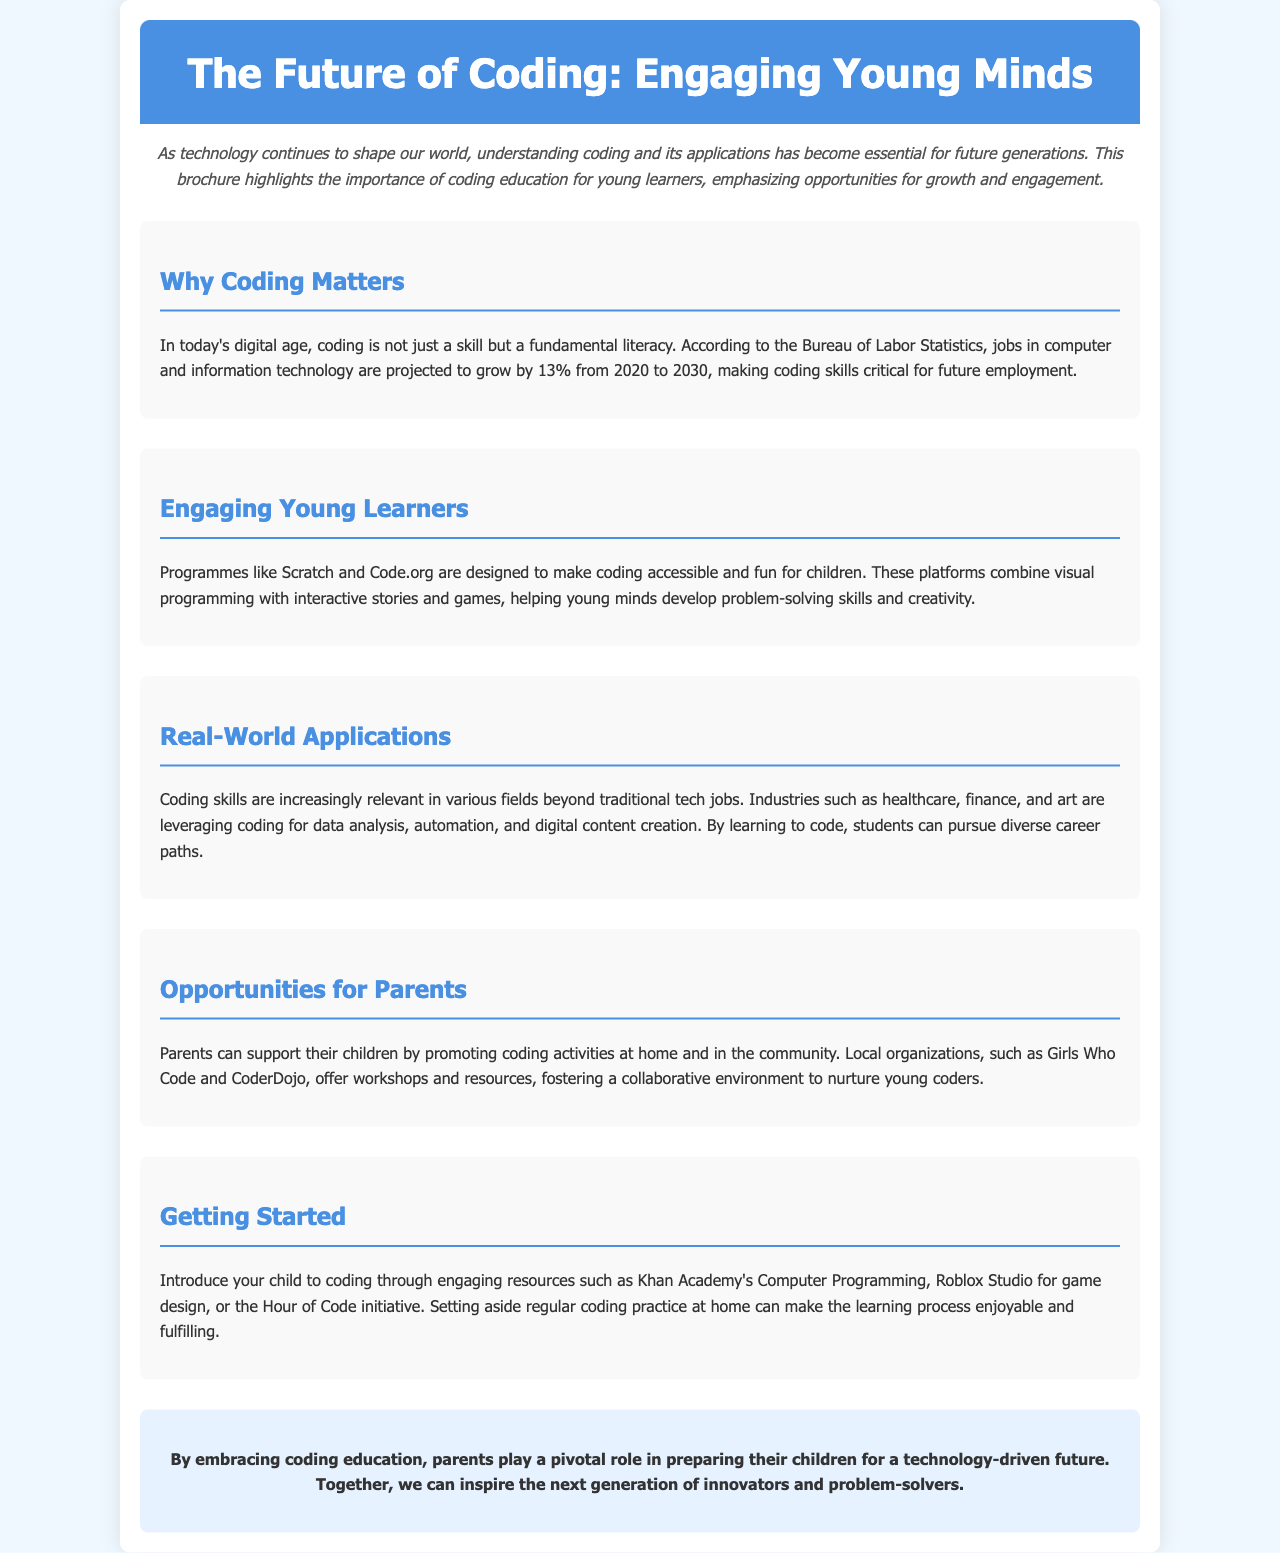What is the title of the brochure? The title is prominently displayed at the top of the brochure, indicating its main theme.
Answer: The Future of Coding: Engaging Young Minds What percentage is the projected job growth in computer and information technology from 2020 to 2030? The document refers to a specific percentage concerning future job growth based on statistics.
Answer: 13% Which platforms are mentioned as engaging young learners in coding? The brochure lists specific programs that are designed to make coding fun and accessible for children.
Answer: Scratch and Code.org What is suggested as a way for parents to support their children's coding education? The document discusses specific actions that parents can take to help promote coding outside of school.
Answer: Promote coding activities at home What is one resource listed to help introduce children to coding? The brochure provides examples of resources parents can use to help their children begin learning coding.
Answer: Khan Academy's Computer Programming What role do parents play in coding education, according to the conclusion? The conclusion emphasizes a specific responsibility held by parents concerning their children's education.
Answer: Pivotal role 